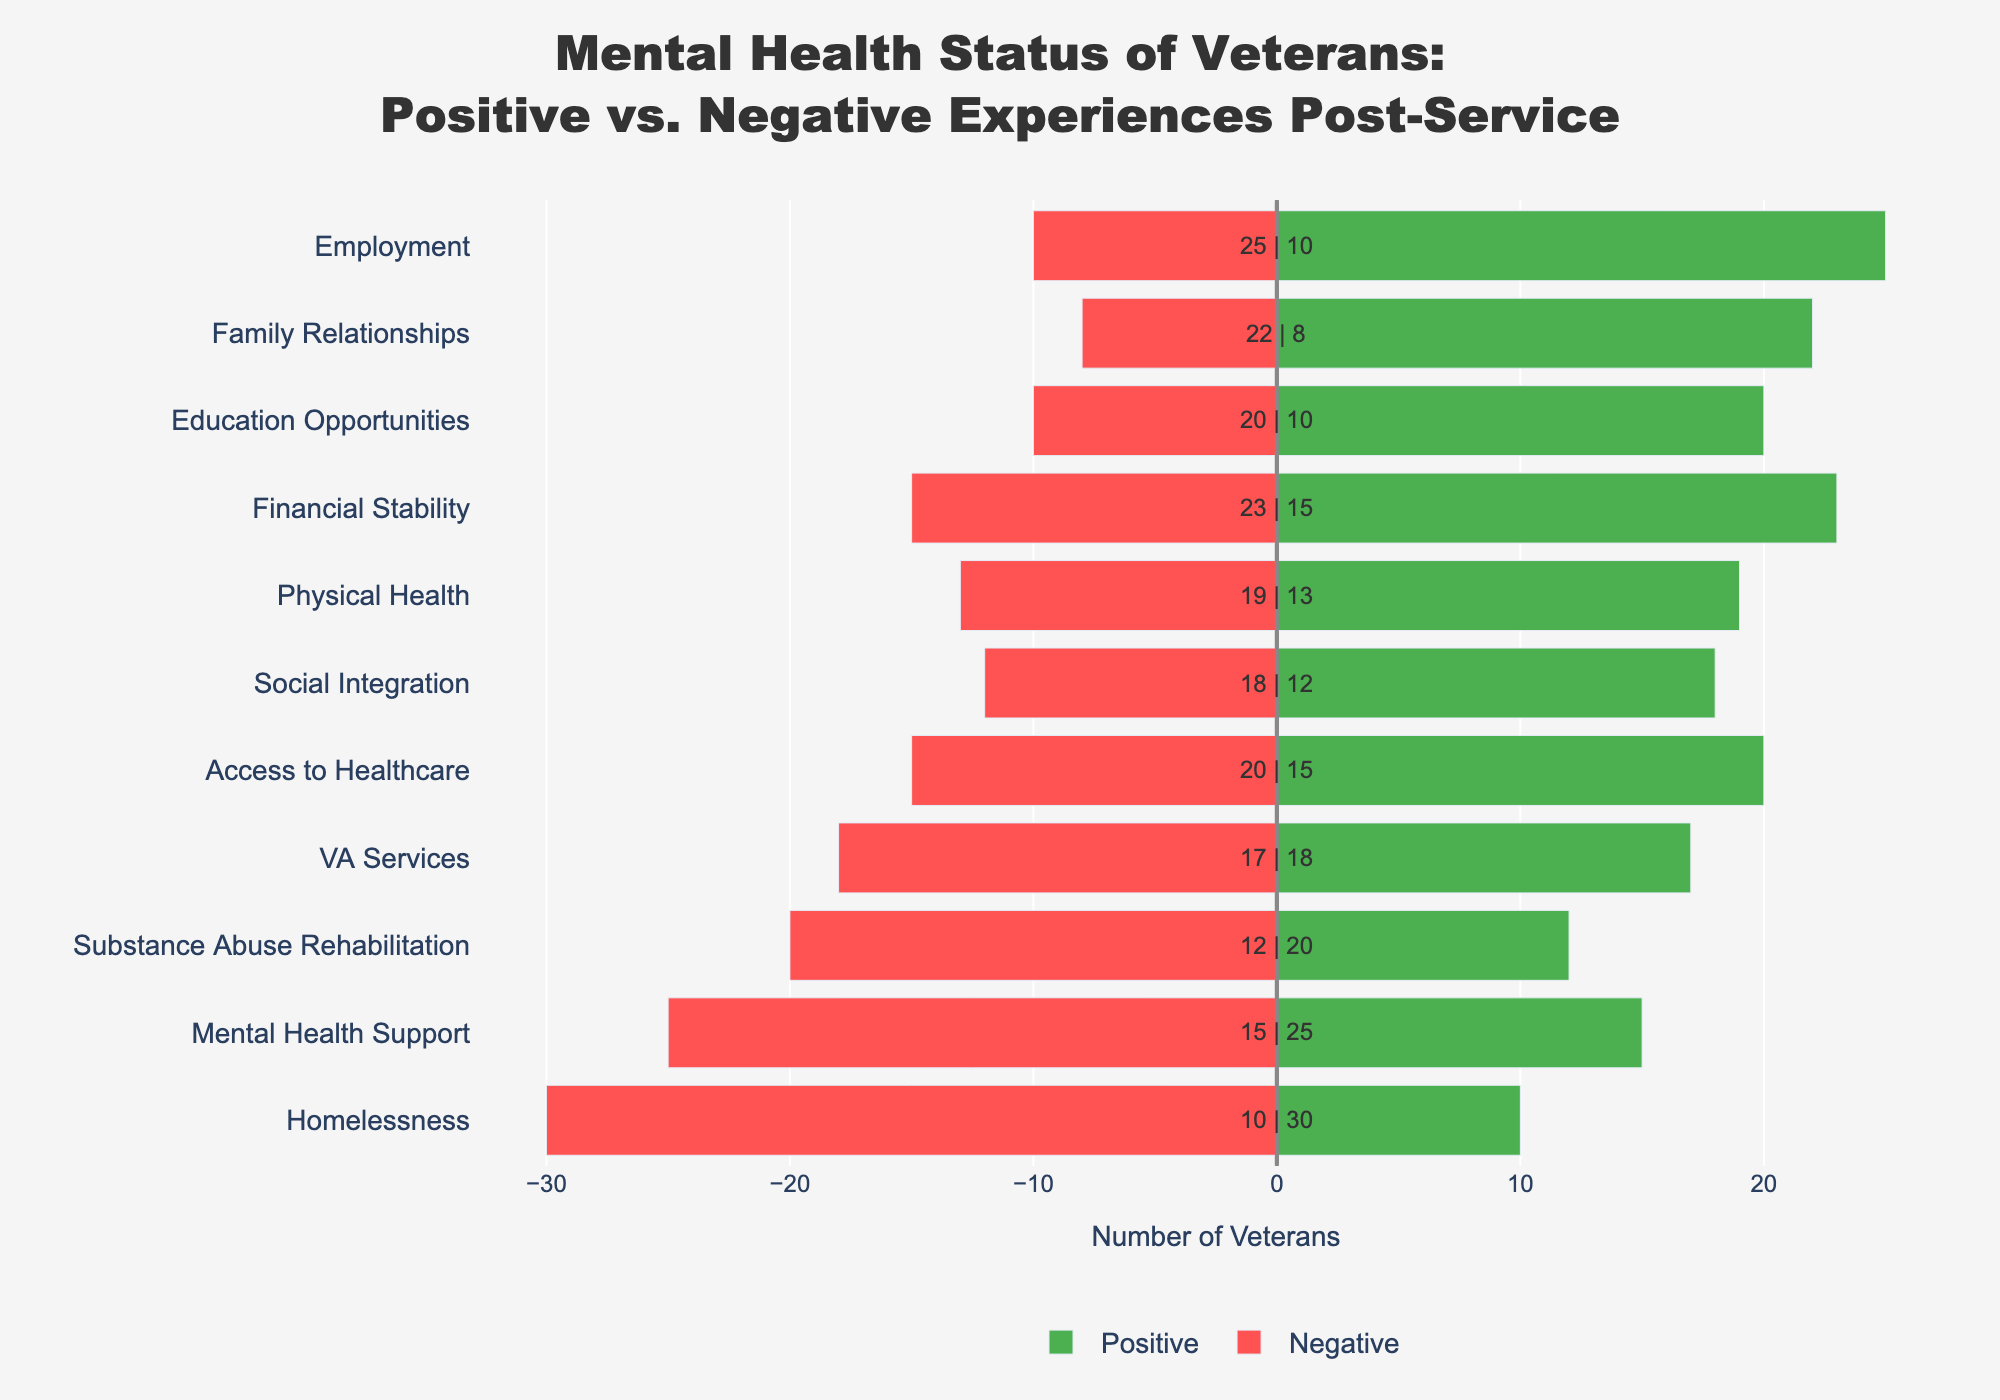Experience has the highest positive difference between Positive and Negative experiences? Look at the Positive and Negative values for each experience and calculate the difference. The highest positive difference is 14 for Employment (25 - 10).
Answer: Employment Which experience has the highest negative impact on veterans post-service? Observe the lengths of the red bars. The longest red bar represents Homelessness with a value of 30.
Answer: Homelessness What is the combined total number of veterans who had positive experiences in Access to Healthcare and Education Opportunities? Add the Positive values for Access to Healthcare (20) and Education Opportunities (20). The sum is 20 + 20 = 40.
Answer: 40 Which experience shows more veterans reporting positive experiences than negative but has less than 5 difference between the two? Look for experiences where the Positive value is higher but the difference is less than 5. Education Opportunities and Social Integration have Positive values of 20 and 18, respectively, versus Negative values 10 and 12, respectively. The differences are 10 and 6. Only Social Integration fits the 5 difference criteria.
Answer: Social Integration Which experience has the smallest gap between Positive and Negative experiences? Identify the experiences where the difference between Positive and Negative is the smallest. VA Services has Positive 17 and Negative 18, and the difference is 1.
Answer: VA Services What are the experiences where Positive experiences outweigh Negative by more than 10 veterans? Check where the Positive - Negative difference is more than 10. Employment (15), Family Relationships (14), Education Opportunities (10), and Financial Stability (8) qualify, but only Employment and Family Relationships satisfy the greater than 10 criteria.
Answer: Employment, Family Relationships Which experience shows a greater number of Negative than Positive mental health support experiences and by how much? Find out where Negative values are higher than Positive for Mental Health Support. Mental Health Support shows 25 Negative and 15 Positive; the difference is 10.
Answer: Mental Health Support, 10 How many more veterans had positive experiences in Social Integration than those in Substance Abuse Rehabilitation? Subtract Positive values of Substance Abuse Rehabilitation (12) from Social Integration (18). The difference is 18 - 12 = 6.
Answer: 6 Which category indicates an equal balance between Positive and Negative experiences? Find a category where Positive and Negative values are the same. Such an experience doesn't exist.
Answer: None 